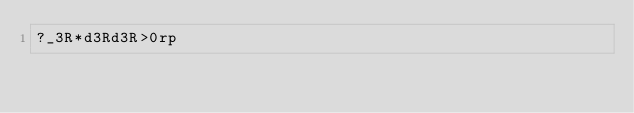Convert code to text. <code><loc_0><loc_0><loc_500><loc_500><_dc_>?_3R*d3Rd3R>0rp</code> 